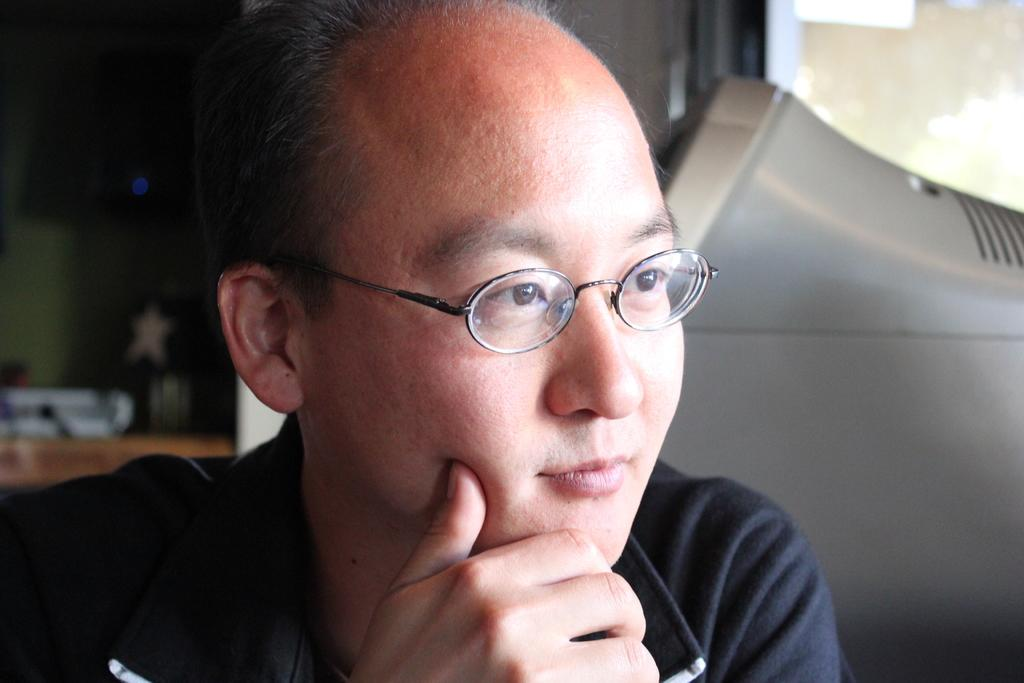What is present in the image? There is a person in the image. Can you describe the person's appearance? The person is wearing spectacles. What else can be seen in the image besides the person? There are objects visible around the person. Can you tell me how many boats are visible in the image? There are no boats present in the image. What type of vase is located on the table in the image? There is no vase present in the image. 